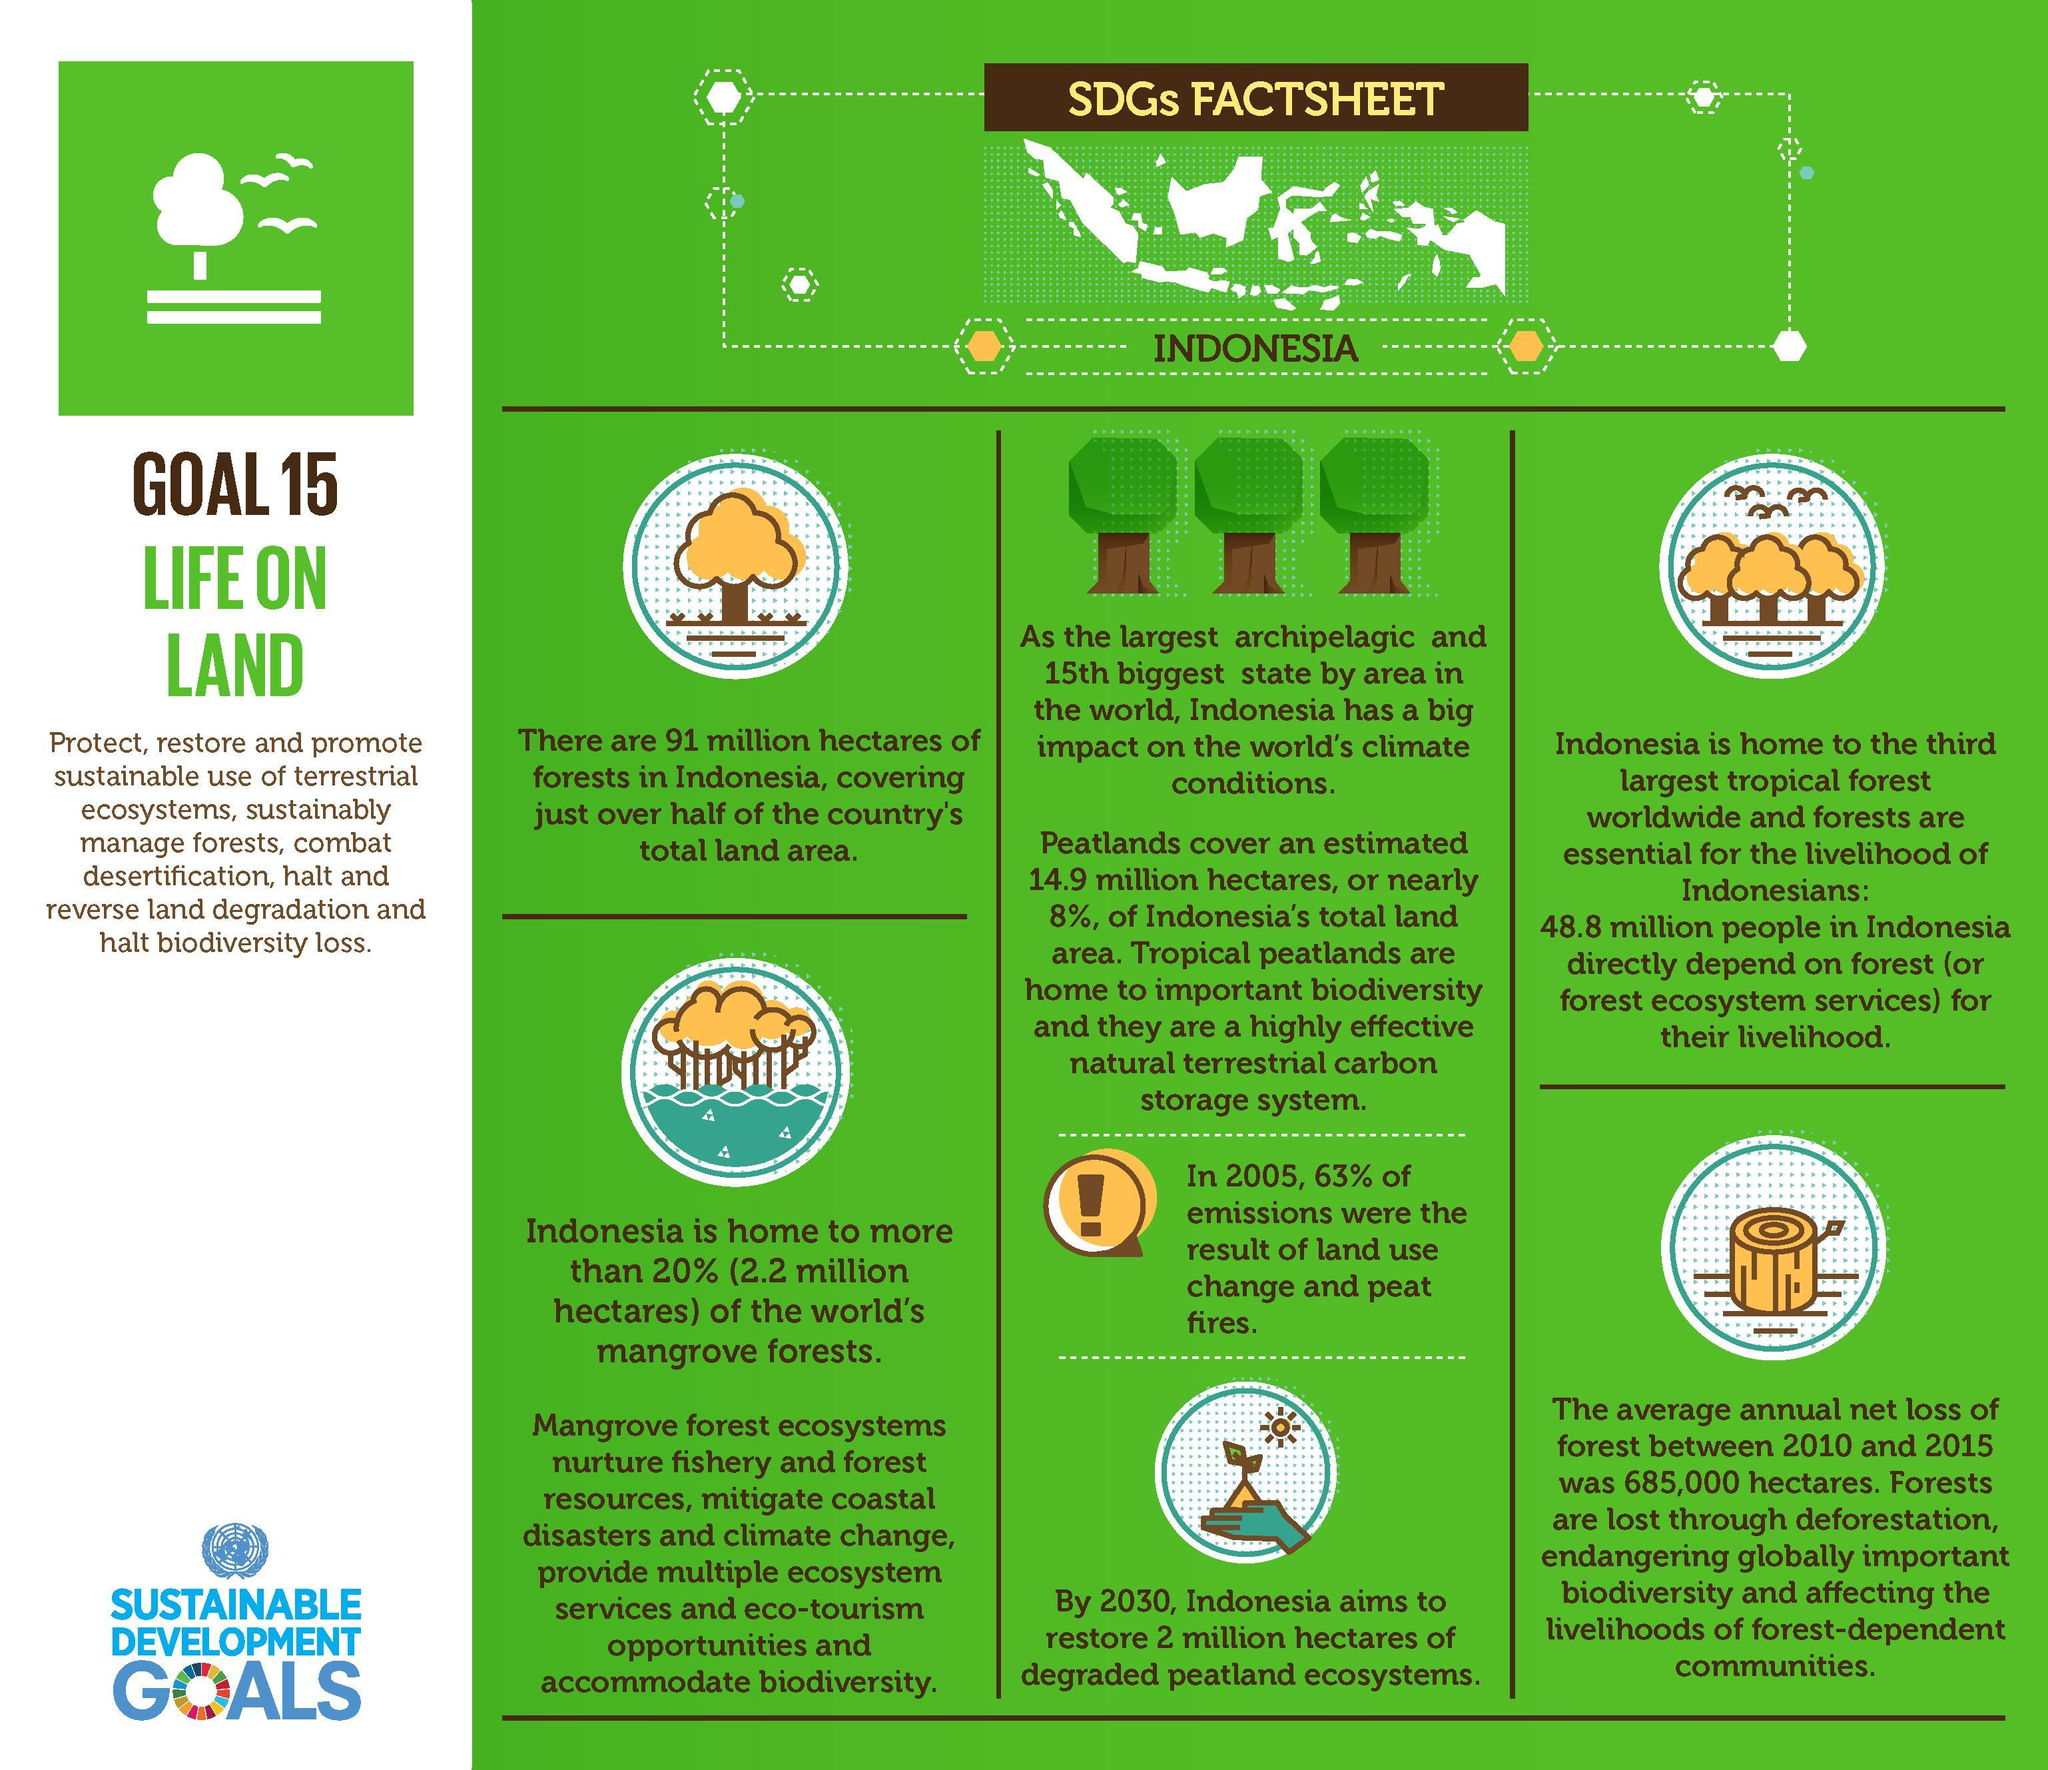How many hectare area of degraded peatland ecosystem in Indonesia is expected to be restored by 2030?
Answer the question with a short phrase. 2 million hectares What population in Indonesia directly depend on forest for their livelihood? 48.8 million What percentage of Indonesia's total land area is covered by Peatlands? nearly 8% What is the forest area in Indonesia? 91 million hectares How many hectare area of world's mangrove forests is in Indonesia? 2.2 million hectares 